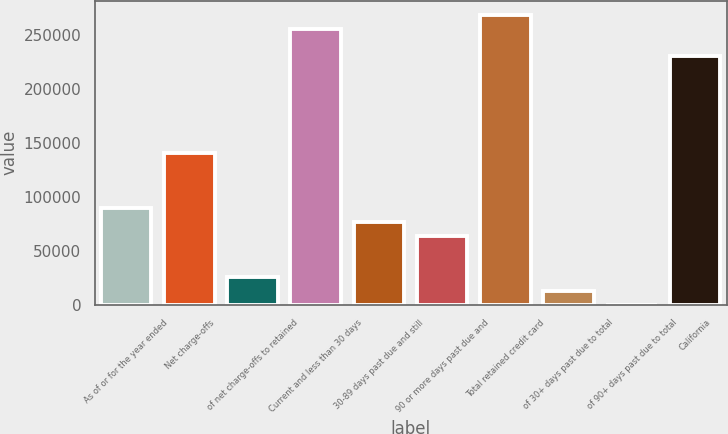<chart> <loc_0><loc_0><loc_500><loc_500><bar_chart><fcel>As of or for the year ended<fcel>Net charge-offs<fcel>of net charge-offs to retained<fcel>Current and less than 30 days<fcel>30-89 days past due and still<fcel>90 or more days past due and<fcel>Total retained credit card<fcel>of 30+ days past due to total<fcel>of 90+ days past due to total<fcel>California<nl><fcel>89595.4<fcel>140792<fcel>25599.4<fcel>255985<fcel>76796.2<fcel>63997<fcel>268784<fcel>12800.2<fcel>1.02<fcel>230387<nl></chart> 